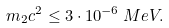Convert formula to latex. <formula><loc_0><loc_0><loc_500><loc_500>m _ { 2 } c ^ { 2 } \leq 3 \cdot 1 0 ^ { - 6 } \, M e V .</formula> 